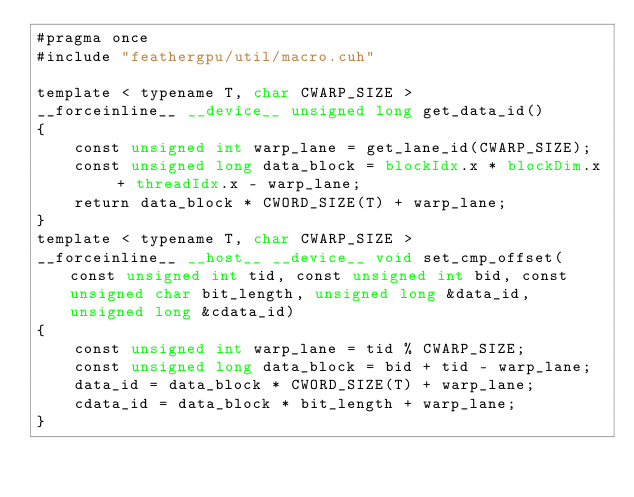<code> <loc_0><loc_0><loc_500><loc_500><_Cuda_>#pragma once
#include "feathergpu/util/macro.cuh"

template < typename T, char CWARP_SIZE >
__forceinline__ __device__ unsigned long get_data_id()
{
    const unsigned int warp_lane = get_lane_id(CWARP_SIZE);
    const unsigned long data_block = blockIdx.x * blockDim.x + threadIdx.x - warp_lane;
    return data_block * CWORD_SIZE(T) + warp_lane;
}
template < typename T, char CWARP_SIZE >
__forceinline__ __host__ __device__ void set_cmp_offset(const unsigned int tid, const unsigned int bid, const unsigned char bit_length, unsigned long &data_id, unsigned long &cdata_id)
{
    const unsigned int warp_lane = tid % CWARP_SIZE;
    const unsigned long data_block = bid + tid - warp_lane;
    data_id = data_block * CWORD_SIZE(T) + warp_lane;
    cdata_id = data_block * bit_length + warp_lane;
}

</code> 